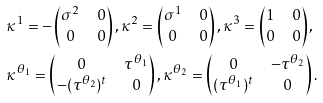<formula> <loc_0><loc_0><loc_500><loc_500>& \kappa ^ { 1 } = - \begin{pmatrix} \sigma ^ { 2 } & 0 \\ 0 & 0 \end{pmatrix} , \kappa ^ { 2 } = \begin{pmatrix} \sigma ^ { 1 } & 0 \\ 0 & 0 \end{pmatrix} , \kappa ^ { 3 } = \begin{pmatrix} 1 & 0 \\ 0 & 0 \end{pmatrix} , \\ & \kappa ^ { \theta _ { 1 } } = \begin{pmatrix} 0 & \tau ^ { \theta _ { 1 } } \\ - ( \tau ^ { \theta _ { 2 } } ) ^ { t } & 0 \end{pmatrix} , \kappa ^ { \theta _ { 2 } } = \begin{pmatrix} 0 & - \tau ^ { \theta _ { 2 } } \\ ( \tau ^ { \theta _ { 1 } } ) ^ { t } & 0 \end{pmatrix} .</formula> 